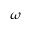<formula> <loc_0><loc_0><loc_500><loc_500>\omega</formula> 